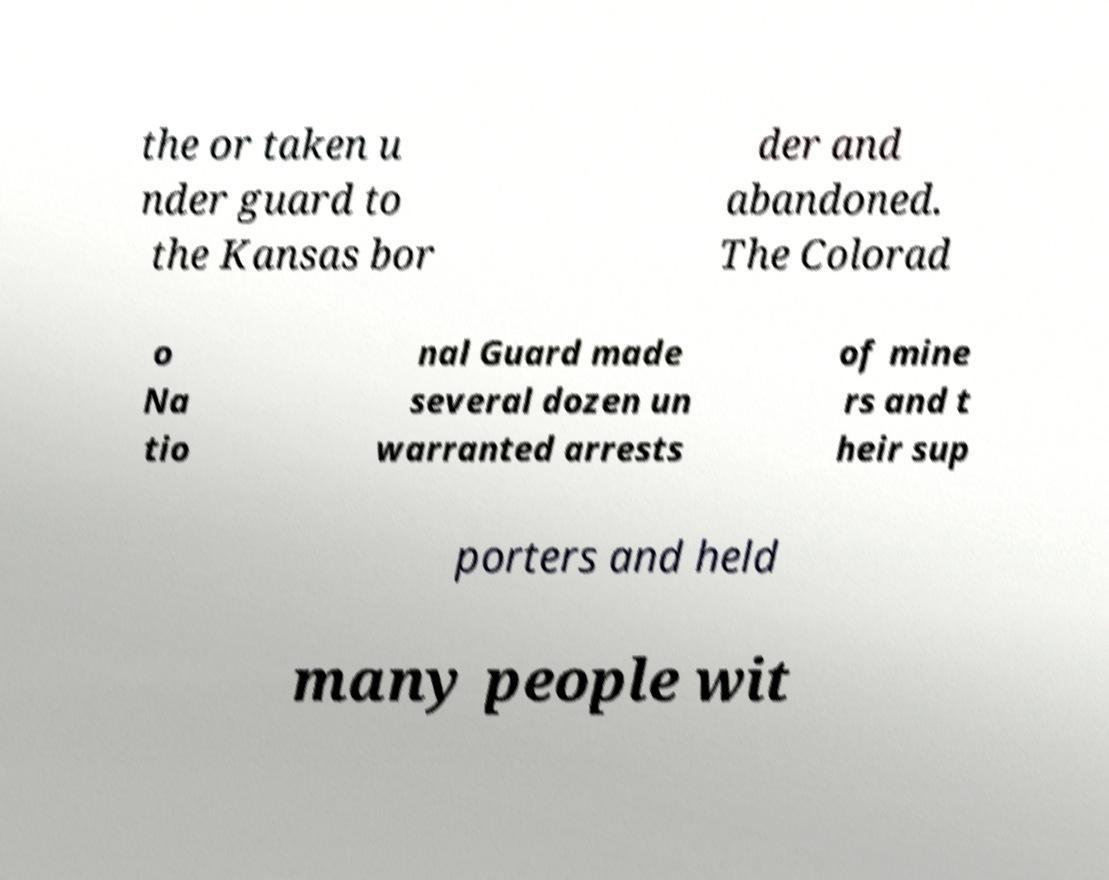Please identify and transcribe the text found in this image. the or taken u nder guard to the Kansas bor der and abandoned. The Colorad o Na tio nal Guard made several dozen un warranted arrests of mine rs and t heir sup porters and held many people wit 